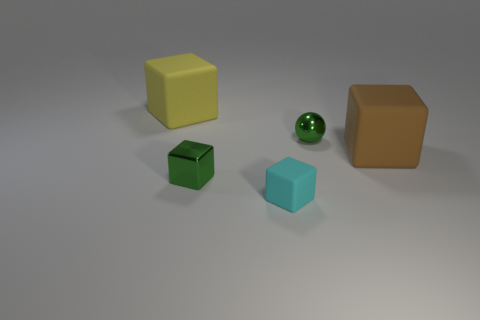Is there a tiny thing of the same color as the sphere?
Your answer should be compact. Yes. Do the brown thing and the large yellow thing have the same shape?
Offer a terse response. Yes. What number of small objects are yellow objects or blue spheres?
Your answer should be compact. 0. What color is the tiny object that is the same material as the sphere?
Keep it short and to the point. Green. What number of large blocks have the same material as the small cyan object?
Your answer should be compact. 2. There is a object to the right of the green ball; is its size the same as the rubber cube left of the cyan thing?
Make the answer very short. Yes. The large block to the left of the metal object behind the large brown block is made of what material?
Your answer should be very brief. Rubber. Are there fewer big brown matte cubes that are in front of the tiny green ball than green metallic blocks to the right of the big brown block?
Ensure brevity in your answer.  No. What material is the tiny block that is the same color as the ball?
Ensure brevity in your answer.  Metal. What is the big thing that is behind the sphere made of?
Your response must be concise. Rubber. 